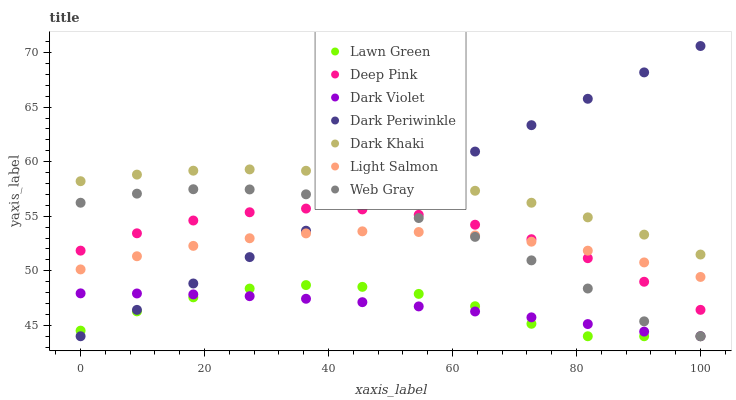Does Lawn Green have the minimum area under the curve?
Answer yes or no. Yes. Does Dark Periwinkle have the maximum area under the curve?
Answer yes or no. Yes. Does Light Salmon have the minimum area under the curve?
Answer yes or no. No. Does Light Salmon have the maximum area under the curve?
Answer yes or no. No. Is Dark Periwinkle the smoothest?
Answer yes or no. Yes. Is Web Gray the roughest?
Answer yes or no. Yes. Is Light Salmon the smoothest?
Answer yes or no. No. Is Light Salmon the roughest?
Answer yes or no. No. Does Lawn Green have the lowest value?
Answer yes or no. Yes. Does Light Salmon have the lowest value?
Answer yes or no. No. Does Dark Periwinkle have the highest value?
Answer yes or no. Yes. Does Light Salmon have the highest value?
Answer yes or no. No. Is Dark Violet less than Light Salmon?
Answer yes or no. Yes. Is Dark Khaki greater than Web Gray?
Answer yes or no. Yes. Does Dark Periwinkle intersect Lawn Green?
Answer yes or no. Yes. Is Dark Periwinkle less than Lawn Green?
Answer yes or no. No. Is Dark Periwinkle greater than Lawn Green?
Answer yes or no. No. Does Dark Violet intersect Light Salmon?
Answer yes or no. No. 